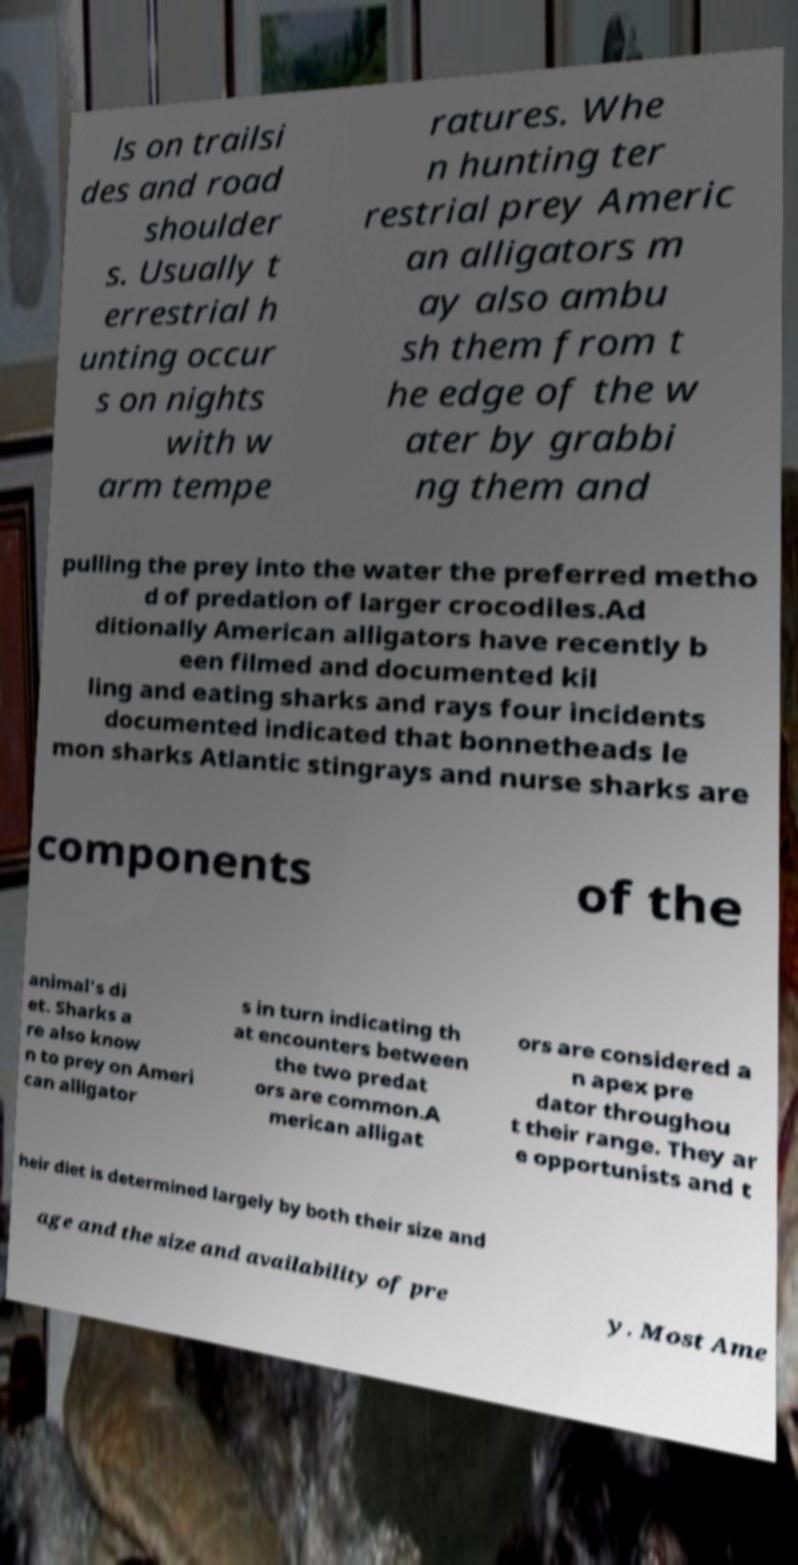There's text embedded in this image that I need extracted. Can you transcribe it verbatim? ls on trailsi des and road shoulder s. Usually t errestrial h unting occur s on nights with w arm tempe ratures. Whe n hunting ter restrial prey Americ an alligators m ay also ambu sh them from t he edge of the w ater by grabbi ng them and pulling the prey into the water the preferred metho d of predation of larger crocodiles.Ad ditionally American alligators have recently b een filmed and documented kil ling and eating sharks and rays four incidents documented indicated that bonnetheads le mon sharks Atlantic stingrays and nurse sharks are components of the animal's di et. Sharks a re also know n to prey on Ameri can alligator s in turn indicating th at encounters between the two predat ors are common.A merican alligat ors are considered a n apex pre dator throughou t their range. They ar e opportunists and t heir diet is determined largely by both their size and age and the size and availability of pre y. Most Ame 